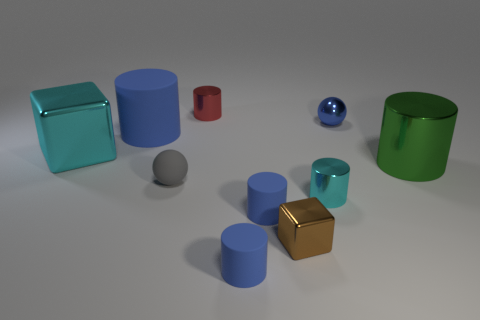What size is the ball on the left side of the red thing?
Offer a very short reply. Small. What shape is the small blue metallic thing that is to the right of the tiny matte cylinder behind the tiny rubber object in front of the tiny brown object?
Your response must be concise. Sphere. What is the shape of the metal object that is both behind the large blue thing and left of the blue ball?
Keep it short and to the point. Cylinder. Is there a cyan object of the same size as the brown cube?
Offer a very short reply. Yes. Do the big object in front of the cyan metal cube and the gray object have the same shape?
Provide a succinct answer. No. Do the small red metal object and the small cyan thing have the same shape?
Offer a very short reply. Yes. Is there another big blue object of the same shape as the big blue object?
Ensure brevity in your answer.  No. What shape is the cyan thing in front of the sphere that is in front of the blue metal sphere?
Ensure brevity in your answer.  Cylinder. What is the color of the small metal cylinder in front of the large rubber cylinder?
Provide a succinct answer. Cyan. What size is the cyan cube that is the same material as the tiny brown object?
Your answer should be very brief. Large. 